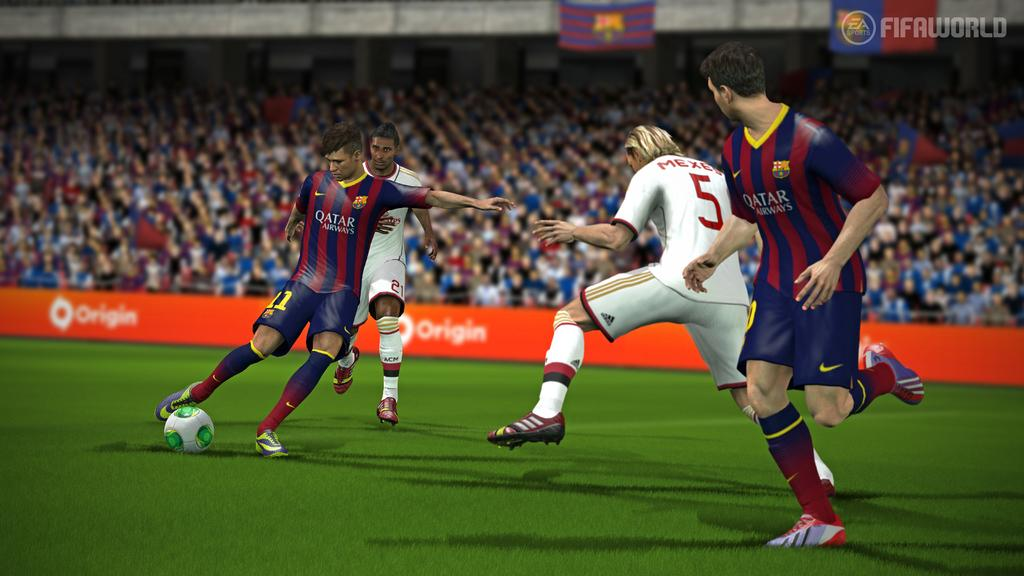<image>
Share a concise interpretation of the image provided. A soccer video game shows an image of a player in a jersey with the text Qatar Airways who is getting reading to shoot a soccer ball. 